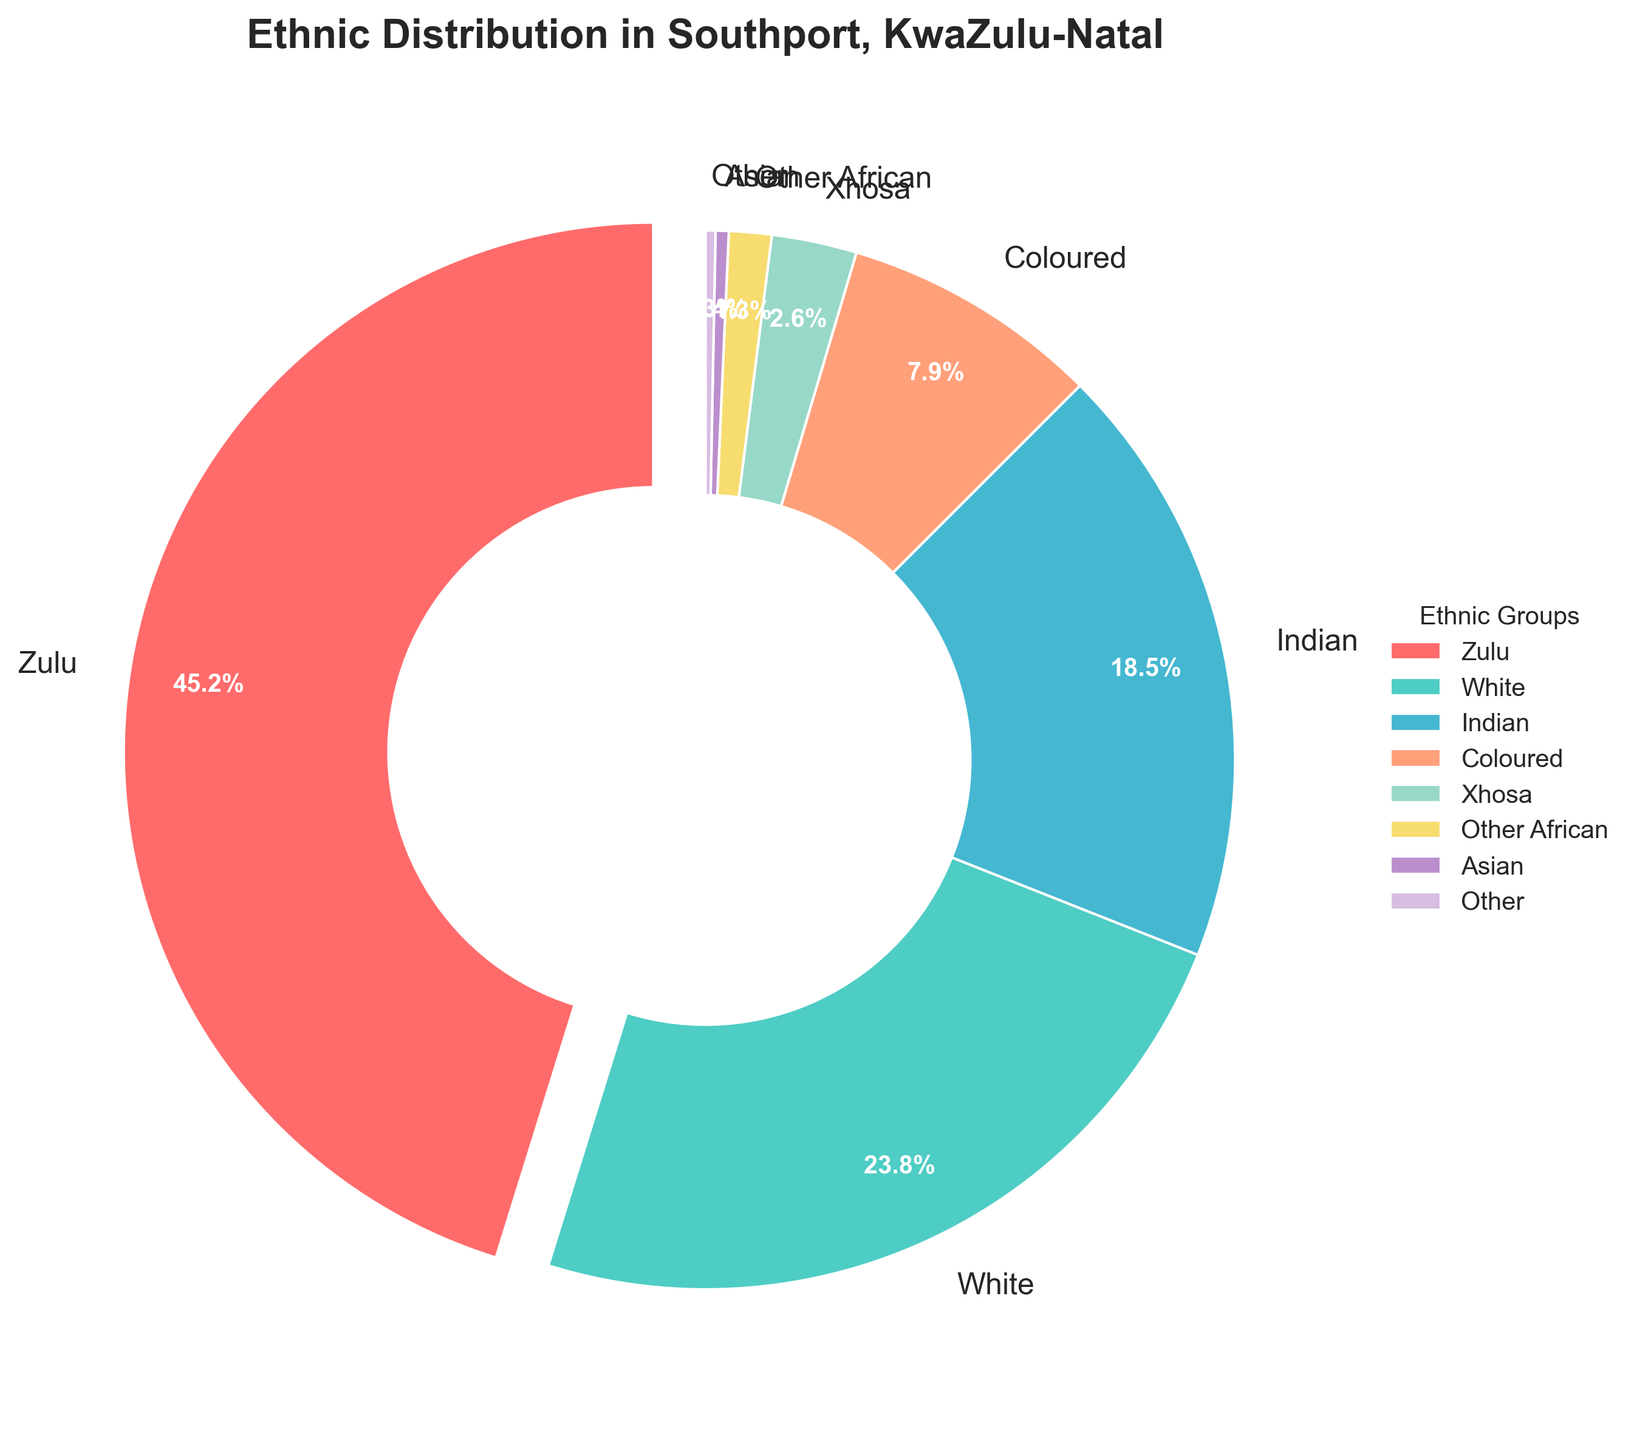Which ethnic group has the highest percentage? The Zulu group has the highest percentage. Observing the pie chart, the largest wedge corresponds to the Zulu group with a percentage of 45.2%.
Answer: Zulu What is the total percentage of the Indian and Coloured ethnic groups combined? To find the combined percentage, sum the percentage of the Indian ethnic group (18.5%) and the Coloured ethnic group (7.9%). 18.5% + 7.9% = 26.4%.
Answer: 26.4% How much larger is the percentage of Zulu compared to the White ethnic group? Subtract the percentage of the White ethnic group (23.8%) from the percentage of the Zulu ethnic group (45.2%). 45.2% - 23.8% = 21.4%.
Answer: 21.4% Which ethnic group has the smallest percentage? The Other group has the smallest percentage. By observing the pie chart, the smallest wedge corresponds to the Other group with a percentage of 0.3%.
Answer: Other What is the percentage point difference between the Indian and Xhosa ethnic groups? Subtract the percentage of the Xhosa ethnic group (2.6%) from the percentage of the Indian ethnic group (18.5%). 18.5% - 2.6% = 15.9%.
Answer: 15.9% Rank the following ethnic groups from highest to lowest based on their percentages: Coloured, White, Indian. Review the individual percentages: White (23.8%), Indian (18.5%), Coloured (7.9%). Therefore, the ranking from highest to lowest is White, Indian, Coloured.
Answer: White, Indian, Coloured If the percentages of Zulu and White were combined, what would be the total percentage? Add the percentage of the Zulu ethnic group (45.2%) and the White ethnic group (23.8%). 45.2% + 23.8% = 69.0%.
Answer: 69.0% Which ethnic group is represented by the blue wedge in the chart? The wedge colored in blue represents the Indian ethnic group. By visually identifying the color corresponding to the label "Indian".
Answer: Indian How does the percentage of the Asian group compare to the Other African group? The percentage of the Asian group is 0.4%, and the Other African group is 1.3%. 0.4% is less than 1.3%.
Answer: Less than What is the total percentage of ethnic groups other than Zulu and White? First, sum the percentages of all groups other than Zulu and White: Indian (18.5%)+ Coloured (7.9%)+ Xhosa (2.6%)+ Other African (1.3%)+ Asian (0.4%)+ Other (0.3%). 
Adding them: 18.5% + 7.9% + 2.6% + 1.3% + 0.4% + 0.3% = 31%.
Answer: 31% 